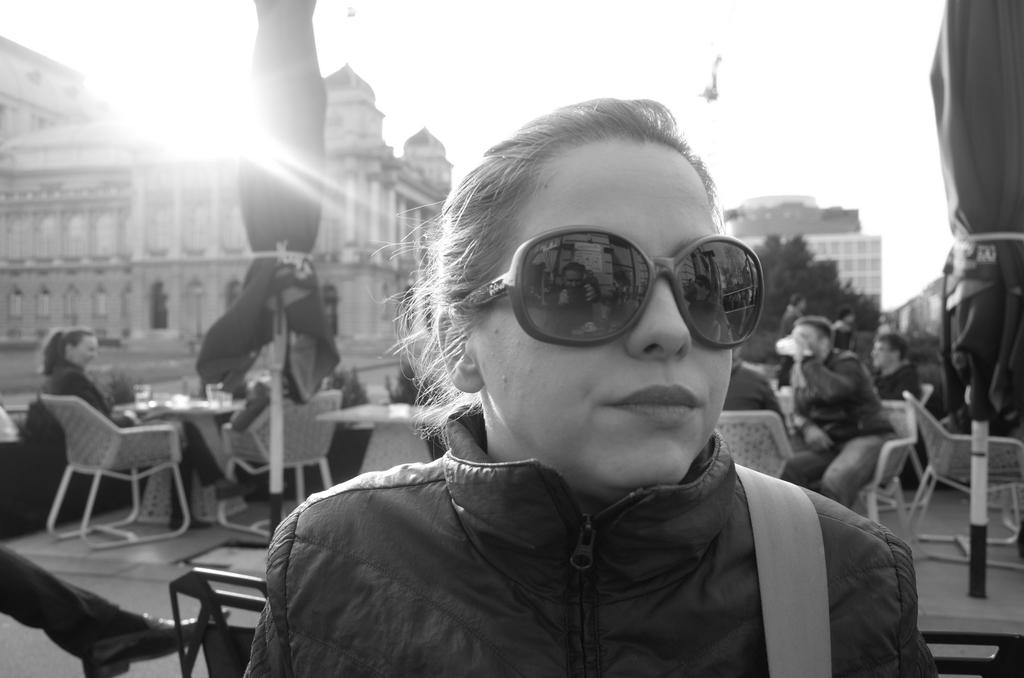What are the persons in the image doing? The persons in the image are sitting on chairs. What is in front of the chairs? There are tables in front of the chairs. Can you describe the woman's attire in the image? The woman is wearing a black jacket. What additional accessory is the woman wearing? The woman in the black jacket is wearing goggles. What can be seen in the distance in the image? There are buildings and trees in the distance. What type of jelly is being served on the tables in the image? There is no jelly present in the image; the tables are empty. What is the selection of trees in the image? The image does not show a selection of trees; it only shows a general view of trees in the distance. 